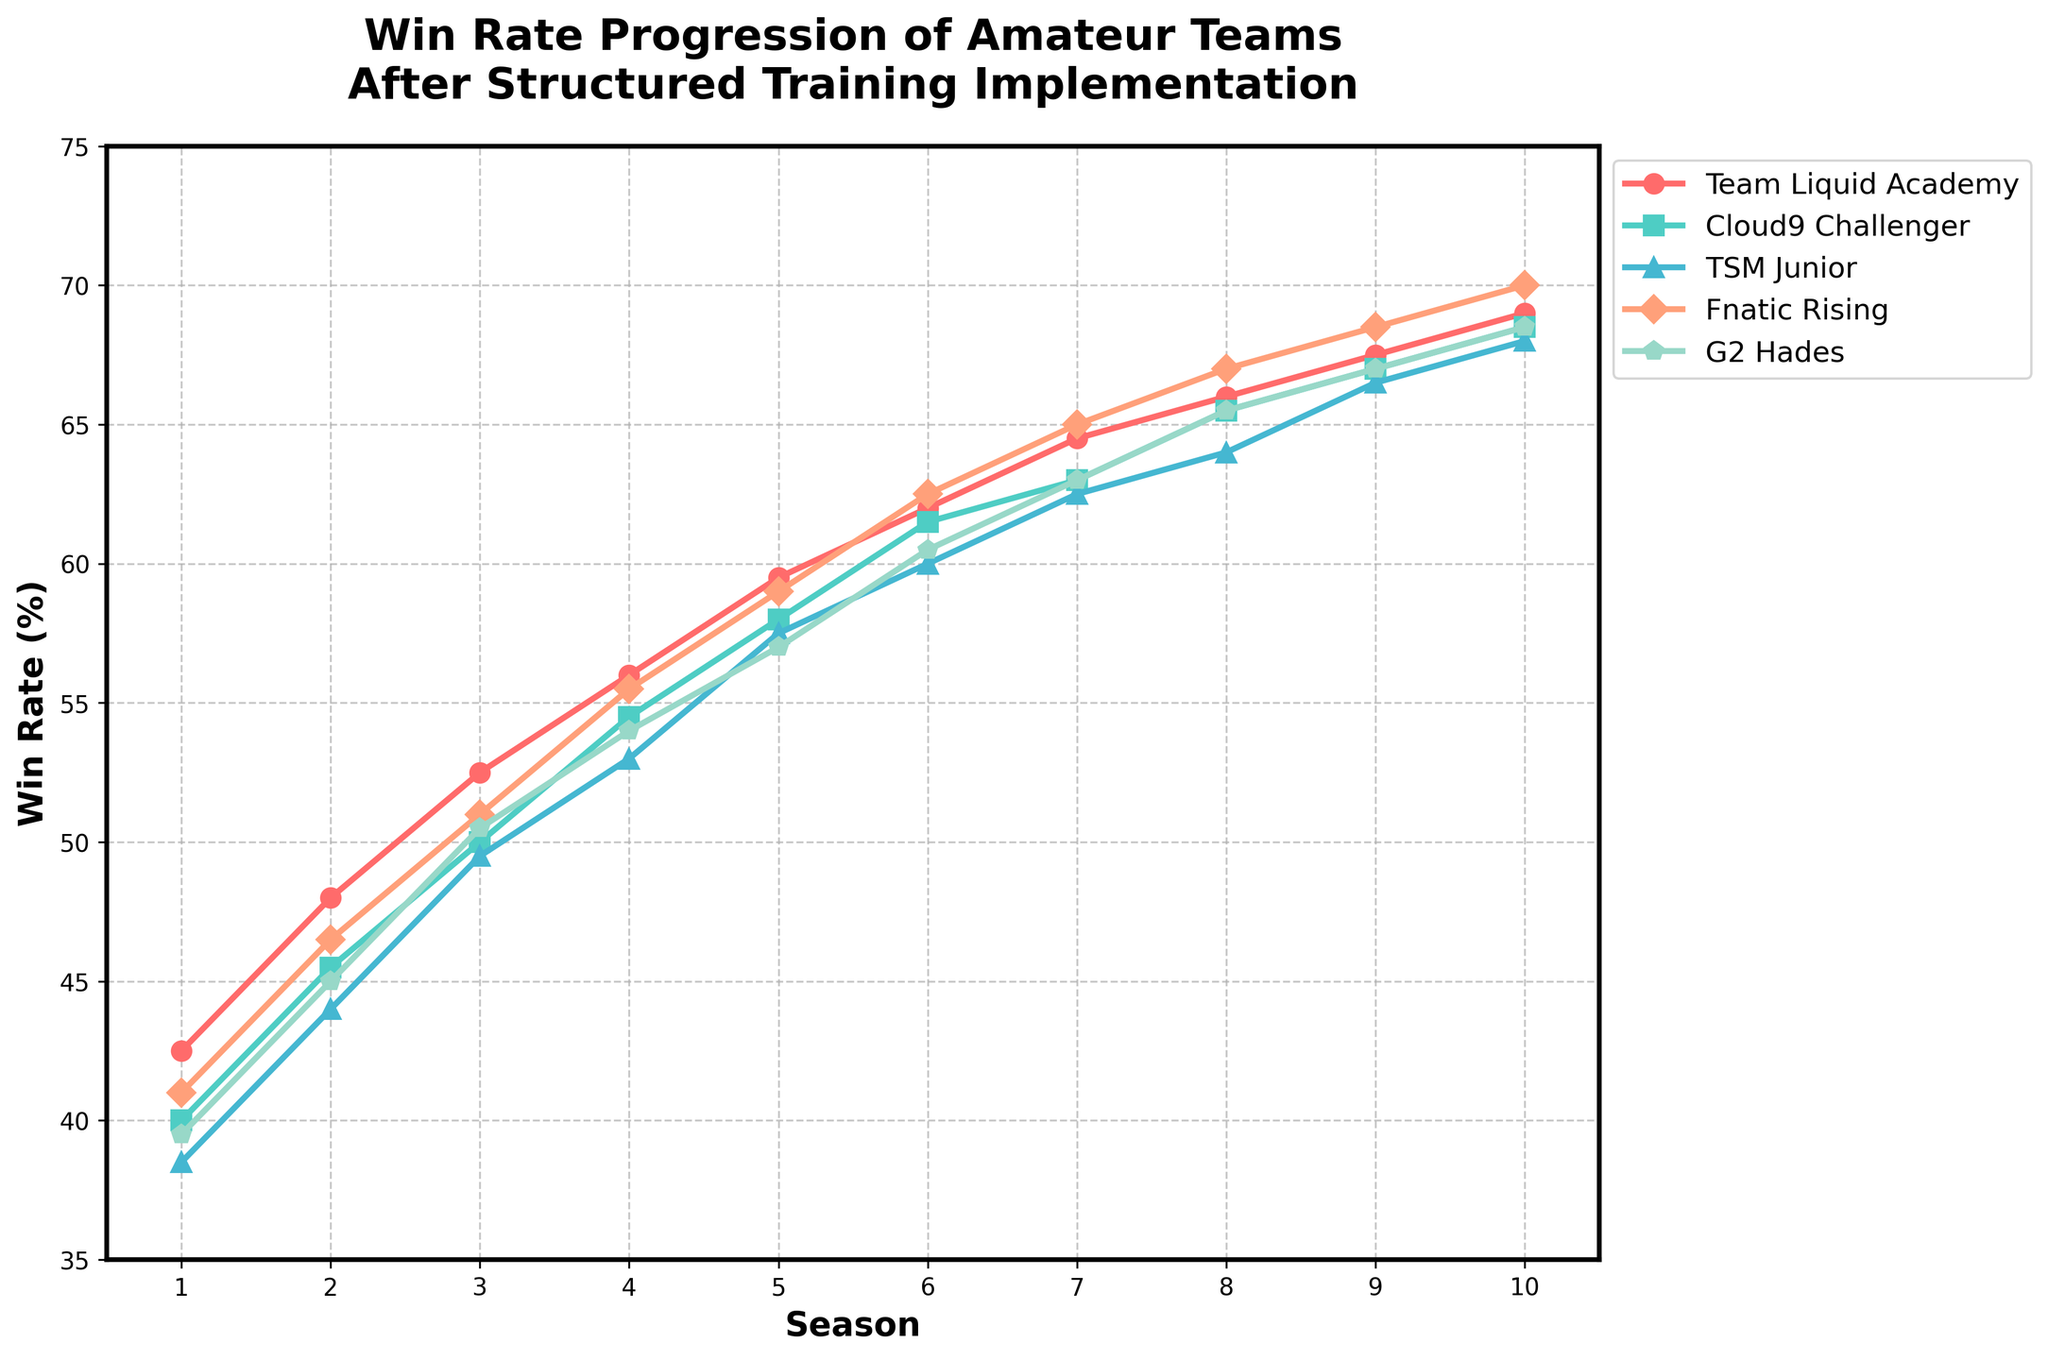What is the overall trend in win rates for Team Liquid Academy from Season 1 to Season 10? The win rate for Team Liquid Academy shows a consistent upward trend from Season 1 (42.5%) to Season 10 (69.0%). Each season, the team’s win rate improves over the previous one.
Answer: Consistent upward trend How much did Cloud9 Challenger’s win rate improve from Season 1 to Season 10? In Season 1, Cloud9 Challenger's win rate was 40.0%, and by Season 10 it had increased to 68.5%. The improvement can be calculated as 68.5% - 40.0% = 28.5%.
Answer: 28.5% Which team had the highest win rate in Season 5? In Season 5, the win rates for the teams are: Team Liquid Academy (59.5%), Cloud9 Challenger (58.0%), TSM Junior (57.5%), Fnatic Rising (59.0%), G2 Hades (57.0%). The highest win rate is for Team Liquid Academy at 59.5%.
Answer: Team Liquid Academy Compare the win rate progression of Fnatic Rising and G2 Hades from Season 6 to Season 9. From Season 6 to Season 9:
- Fnatic Rising: 62.5% (S6) -> 65.0% (S7) -> 67.0% (S8) -> 68.5% (S9)
- G2 Hades: 60.5% (S6) -> 63.0% (S7) -> 65.5% (S8) -> 67.0% (S9)
Fnatic Rising shows a slightly higher progression compared to G2 Hades each season.
Answer: Fnatic Rising has slightly higher progression What is the difference in win rates between Team Liquid Academy and TSM Junior in Season 10? In Season 10, Team Liquid Academy’s win rate is 69.0%, while TSM Junior’s win rate is 68.0%. The difference is 69.0% - 68.0% = 1.0%.
Answer: 1.0% Among the five teams, which team shows the least improvement in win rates from Season 1 to Season 10 and what is that improvement? From Season 1 to Season 10, the improvements are:
- Team Liquid Academy: 69.0% - 42.5% = 26.5%
- Cloud9 Challenger: 68.5% - 40.0% = 28.5%
- TSM Junior: 68.0% - 38.5% = 29.5%
- Fnatic Rising: 70.0% - 41.0% = 29.0%
- G2 Hades: 68.5% - 39.5% = 29.0%
Team Liquid Academy shows the least improvement of 26.5%.
Answer: Team Liquid Academy, 26.5% What is the average win rate of Fnatic Rising in the first three seasons? The win rates for Fnatic Rising in the first three seasons are 41.0%, 46.5%, and 51.0%. The average win rate can be calculated as (41.0% + 46.5% + 51.0%) / 3 = 46.17%.
Answer: 46.17% Which two teams had the closest win rates in Season 7? In Season 7, the win rates for the teams are: Team Liquid Academy (64.5%), Cloud9 Challenger (63.0%), TSM Junior (62.5%), Fnatic Rising (65.0%), and G2 Hades (63.0%). Cloud9 Challenger and G2 Hades both have 63.0%.
Answer: Cloud9 Challenger and G2 Hades What was the highest win rate achieved by any team in Season 6? In Season 6, the highest win rates among the teams are: Team Liquid Academy (62.0%), Cloud9 Challenger (61.5%), TSM Junior (60.0%), Fnatic Rising (62.5%), and G2 Hades (60.5%). The highest win rate is 62.5% by Fnatic Rising.
Answer: 62.5% (Fnatic Rising) 